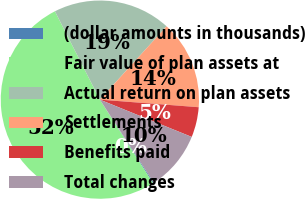Convert chart to OTSL. <chart><loc_0><loc_0><loc_500><loc_500><pie_chart><fcel>(dollar amounts in thousands)<fcel>Fair value of plan assets at<fcel>Actual return on plan assets<fcel>Settlements<fcel>Benefits paid<fcel>Total changes<nl><fcel>0.15%<fcel>51.52%<fcel>19.24%<fcel>14.47%<fcel>4.92%<fcel>9.7%<nl></chart> 